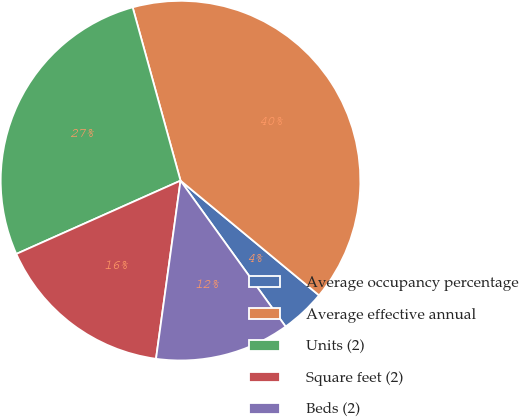Convert chart to OTSL. <chart><loc_0><loc_0><loc_500><loc_500><pie_chart><fcel>Average occupancy percentage<fcel>Average effective annual<fcel>Units (2)<fcel>Square feet (2)<fcel>Beds (2)<nl><fcel>4.06%<fcel>40.29%<fcel>27.39%<fcel>16.14%<fcel>12.11%<nl></chart> 